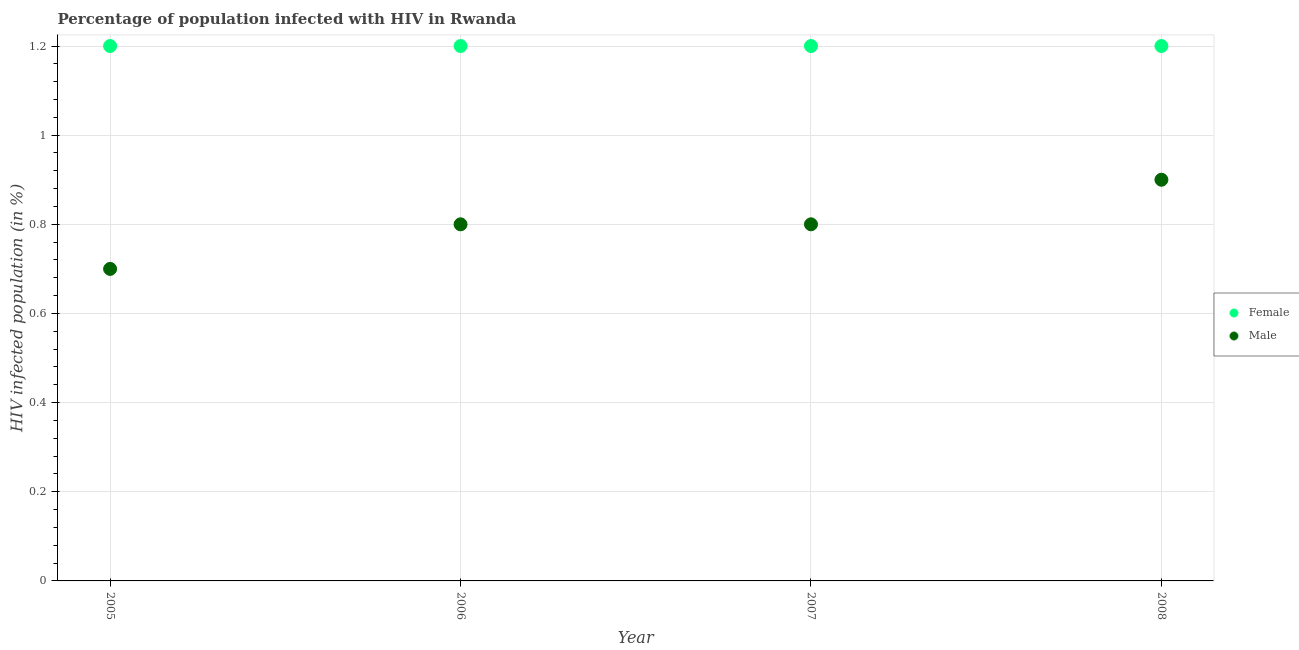How many different coloured dotlines are there?
Offer a very short reply. 2. Across all years, what is the maximum percentage of males who are infected with hiv?
Provide a succinct answer. 0.9. Across all years, what is the minimum percentage of males who are infected with hiv?
Give a very brief answer. 0.7. In which year was the percentage of males who are infected with hiv maximum?
Give a very brief answer. 2008. What is the total percentage of males who are infected with hiv in the graph?
Offer a terse response. 3.2. What is the difference between the percentage of males who are infected with hiv in 2005 and that in 2006?
Your answer should be compact. -0.1. What is the average percentage of males who are infected with hiv per year?
Make the answer very short. 0.8. In the year 2006, what is the difference between the percentage of females who are infected with hiv and percentage of males who are infected with hiv?
Ensure brevity in your answer.  0.4. What is the difference between the highest and the second highest percentage of males who are infected with hiv?
Offer a very short reply. 0.1. What is the difference between the highest and the lowest percentage of males who are infected with hiv?
Make the answer very short. 0.2. In how many years, is the percentage of females who are infected with hiv greater than the average percentage of females who are infected with hiv taken over all years?
Make the answer very short. 0. Does the percentage of females who are infected with hiv monotonically increase over the years?
Your answer should be very brief. No. Is the percentage of males who are infected with hiv strictly greater than the percentage of females who are infected with hiv over the years?
Keep it short and to the point. No. What is the difference between two consecutive major ticks on the Y-axis?
Keep it short and to the point. 0.2. Does the graph contain any zero values?
Provide a short and direct response. No. Does the graph contain grids?
Make the answer very short. Yes. Where does the legend appear in the graph?
Your response must be concise. Center right. What is the title of the graph?
Keep it short and to the point. Percentage of population infected with HIV in Rwanda. Does "Savings" appear as one of the legend labels in the graph?
Provide a short and direct response. No. What is the label or title of the Y-axis?
Offer a very short reply. HIV infected population (in %). What is the HIV infected population (in %) in Female in 2005?
Provide a succinct answer. 1.2. Across all years, what is the maximum HIV infected population (in %) of Female?
Make the answer very short. 1.2. Across all years, what is the maximum HIV infected population (in %) in Male?
Your response must be concise. 0.9. Across all years, what is the minimum HIV infected population (in %) in Female?
Offer a very short reply. 1.2. Across all years, what is the minimum HIV infected population (in %) of Male?
Ensure brevity in your answer.  0.7. What is the difference between the HIV infected population (in %) of Female in 2005 and that in 2006?
Give a very brief answer. 0. What is the difference between the HIV infected population (in %) in Female in 2005 and that in 2007?
Your response must be concise. 0. What is the difference between the HIV infected population (in %) in Female in 2005 and that in 2008?
Make the answer very short. 0. What is the difference between the HIV infected population (in %) of Female in 2006 and that in 2007?
Make the answer very short. 0. What is the difference between the HIV infected population (in %) of Male in 2006 and that in 2007?
Make the answer very short. 0. What is the difference between the HIV infected population (in %) in Female in 2006 and that in 2008?
Offer a very short reply. 0. What is the difference between the HIV infected population (in %) of Male in 2006 and that in 2008?
Give a very brief answer. -0.1. What is the difference between the HIV infected population (in %) in Female in 2005 and the HIV infected population (in %) in Male in 2006?
Your answer should be very brief. 0.4. What is the difference between the HIV infected population (in %) of Female in 2005 and the HIV infected population (in %) of Male in 2008?
Your response must be concise. 0.3. What is the average HIV infected population (in %) of Male per year?
Offer a very short reply. 0.8. In the year 2008, what is the difference between the HIV infected population (in %) of Female and HIV infected population (in %) of Male?
Offer a very short reply. 0.3. What is the ratio of the HIV infected population (in %) of Female in 2005 to that in 2006?
Your response must be concise. 1. What is the ratio of the HIV infected population (in %) in Female in 2005 to that in 2007?
Your answer should be compact. 1. What is the ratio of the HIV infected population (in %) in Male in 2005 to that in 2007?
Give a very brief answer. 0.88. What is the ratio of the HIV infected population (in %) of Female in 2005 to that in 2008?
Your answer should be compact. 1. What is the ratio of the HIV infected population (in %) in Male in 2006 to that in 2007?
Offer a very short reply. 1. What is the ratio of the HIV infected population (in %) of Male in 2006 to that in 2008?
Keep it short and to the point. 0.89. What is the ratio of the HIV infected population (in %) in Female in 2007 to that in 2008?
Keep it short and to the point. 1. What is the difference between the highest and the second highest HIV infected population (in %) in Male?
Your answer should be compact. 0.1. What is the difference between the highest and the lowest HIV infected population (in %) of Female?
Offer a terse response. 0. What is the difference between the highest and the lowest HIV infected population (in %) of Male?
Ensure brevity in your answer.  0.2. 